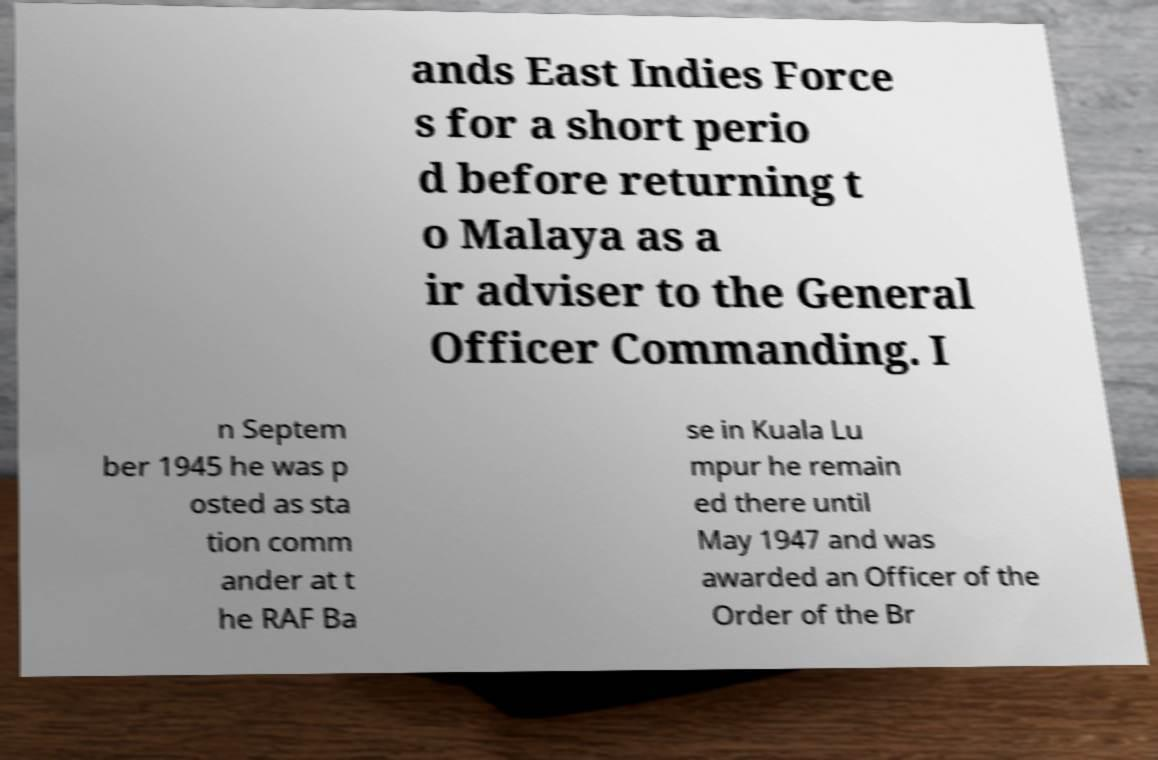For documentation purposes, I need the text within this image transcribed. Could you provide that? ands East Indies Force s for a short perio d before returning t o Malaya as a ir adviser to the General Officer Commanding. I n Septem ber 1945 he was p osted as sta tion comm ander at t he RAF Ba se in Kuala Lu mpur he remain ed there until May 1947 and was awarded an Officer of the Order of the Br 